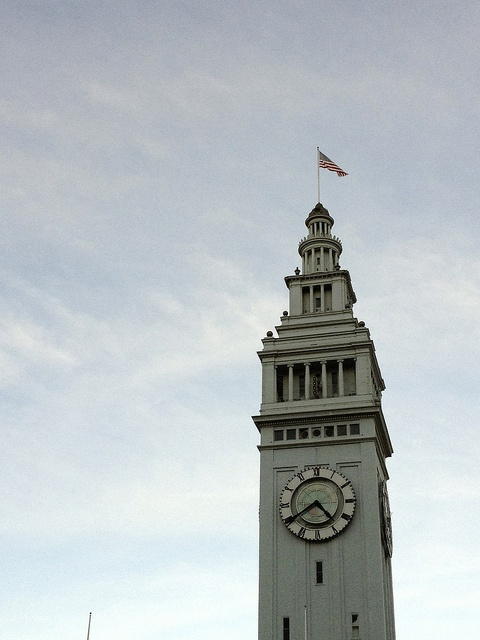Describe the objects in this image and their specific colors. I can see clock in darkgray, gray, and black tones and clock in darkgray, black, and gray tones in this image. 